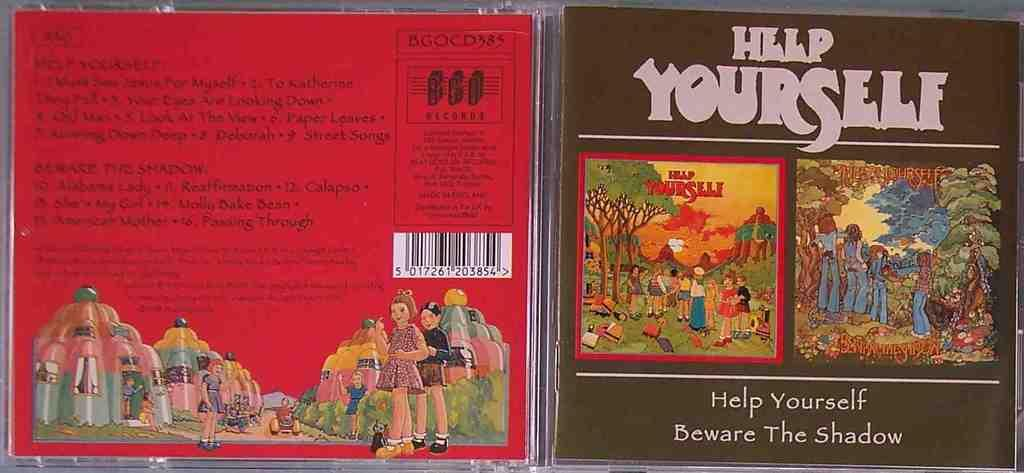<image>
Offer a succinct explanation of the picture presented. The front and back of a CD case called Help Yourself 